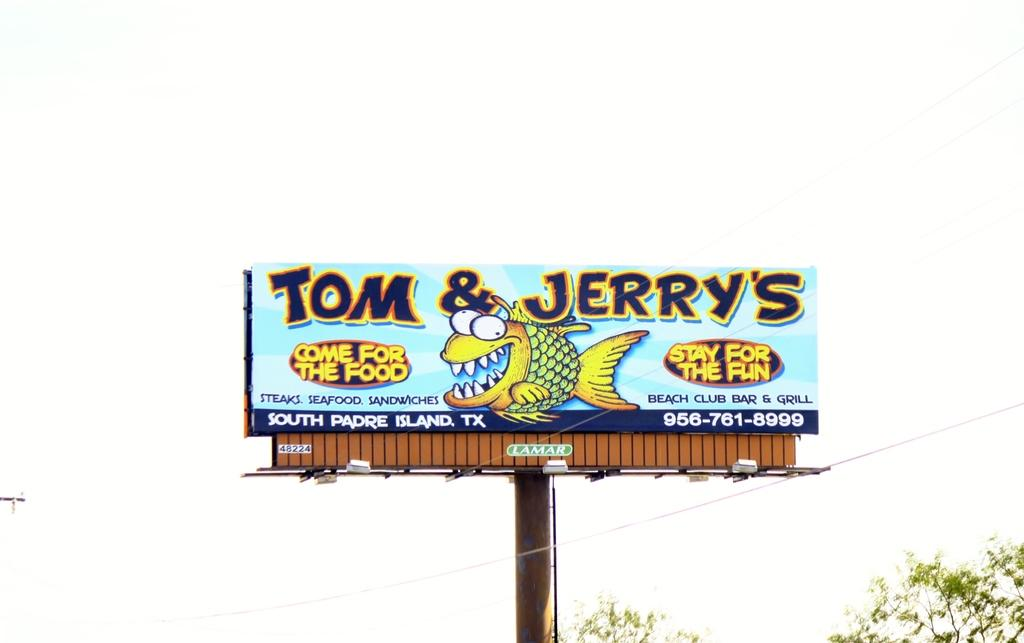<image>
Relay a brief, clear account of the picture shown. a billboard that is advertising Tom & Jerry's seafood 